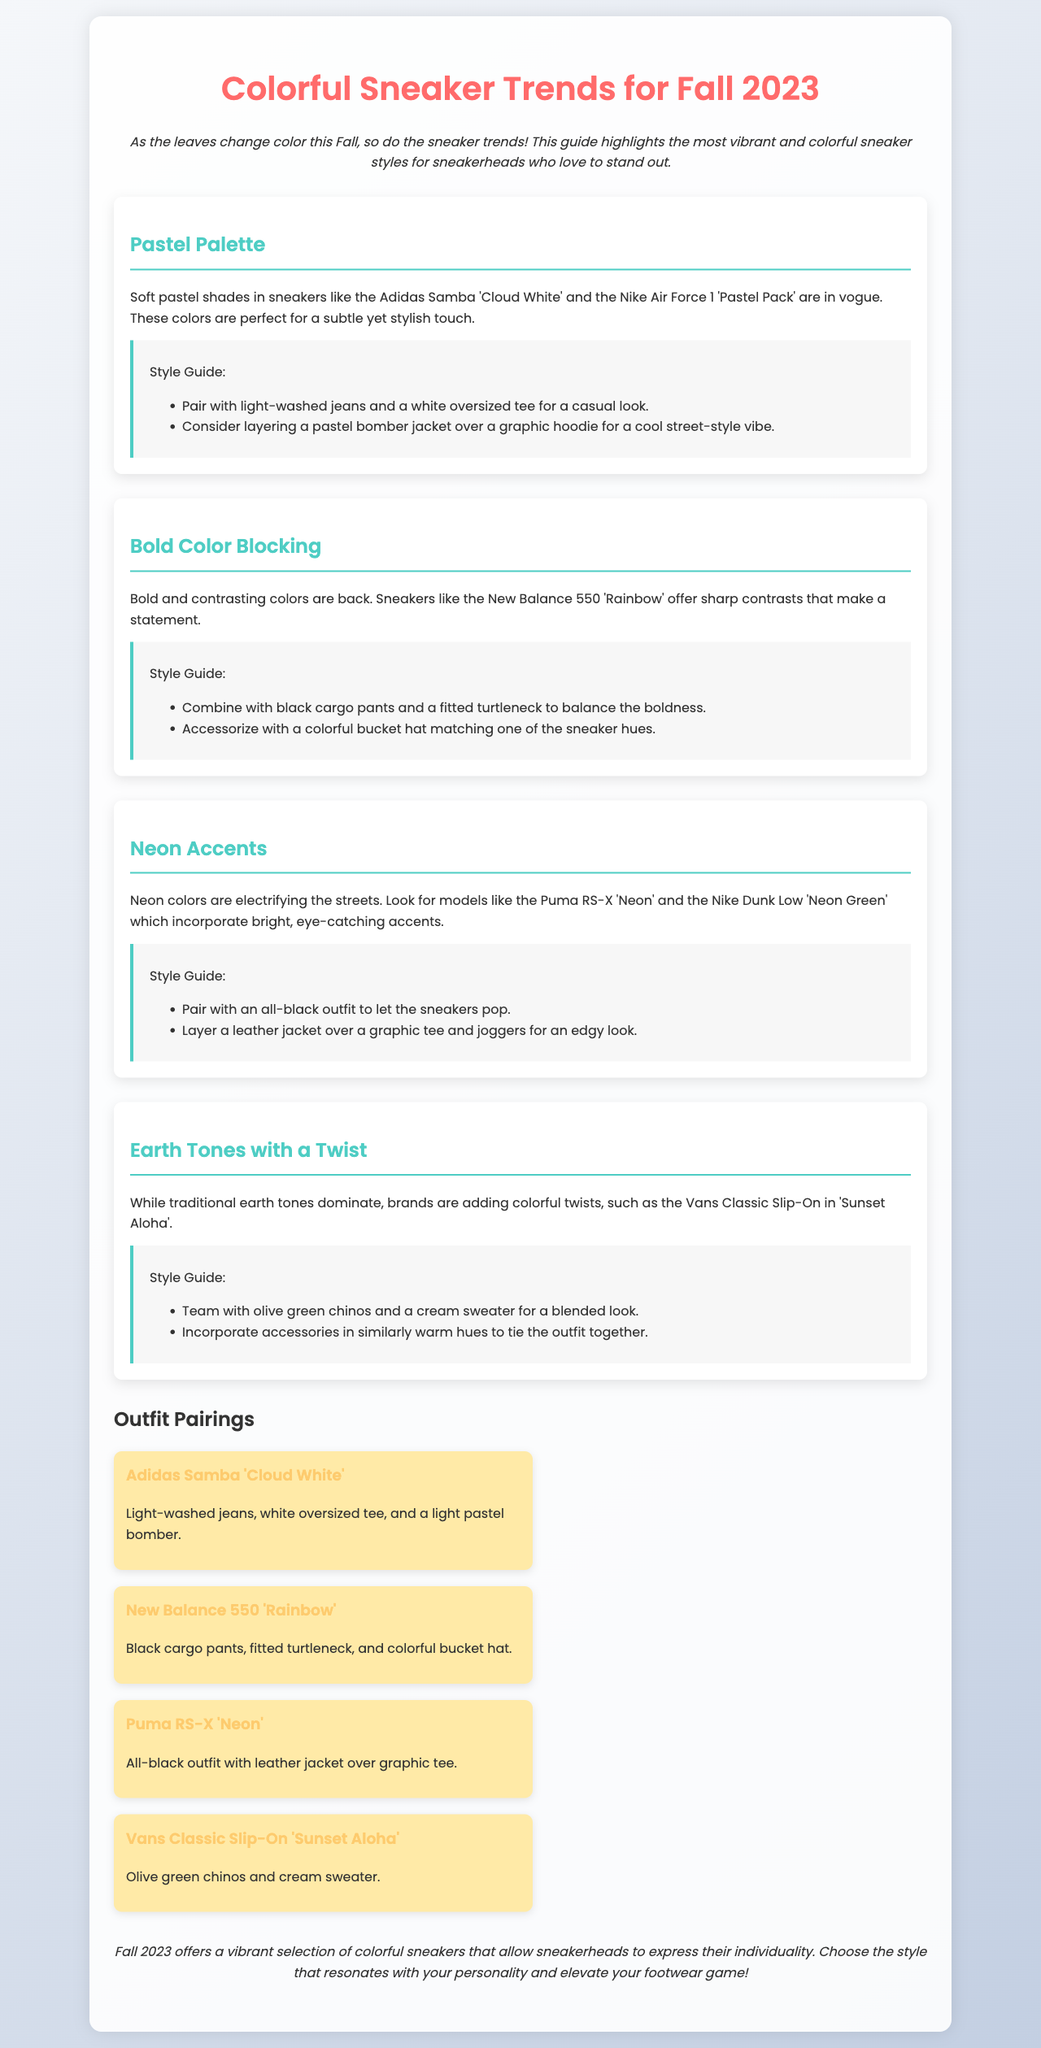What is the title of the document? The title is the main heading presented at the top of the document.
Answer: Colorful Sneaker Trends for Fall 2023 What sneaker model is associated with the Pastel Palette trend? This information can be found in the description of the Pastel Palette trend.
Answer: Adidas Samba 'Cloud White' Which color is highlighted in the Bold Color Blocking trend? This can be identified by looking for the specific color mentioned in the description of the trend.
Answer: Rainbow How should you accessorize with the New Balance 550 'Rainbow'? This is stated in the style guide for the Bold Color Blocking trend.
Answer: Colorful bucket hat What type of outfit is suggested for the Puma RS-X 'Neon'? This is part of the outfit pairings section corresponding to the sneaker.
Answer: All-black outfit with leather jacket What is a recommended pairing for the Vans Classic Slip-On? This is detailed in the outfit pairings section for that sneaker model.
Answer: Olive green chinos and cream sweater What are sneakers with earth tones expected to have? This information is provided in the description for the Earth Tones with a Twist trend.
Answer: Colorful twists How does the document suggest to style sneakers with Neon Accents? This suggests the overall approach for outfits featuring neon sneakers.
Answer: All-black outfit 